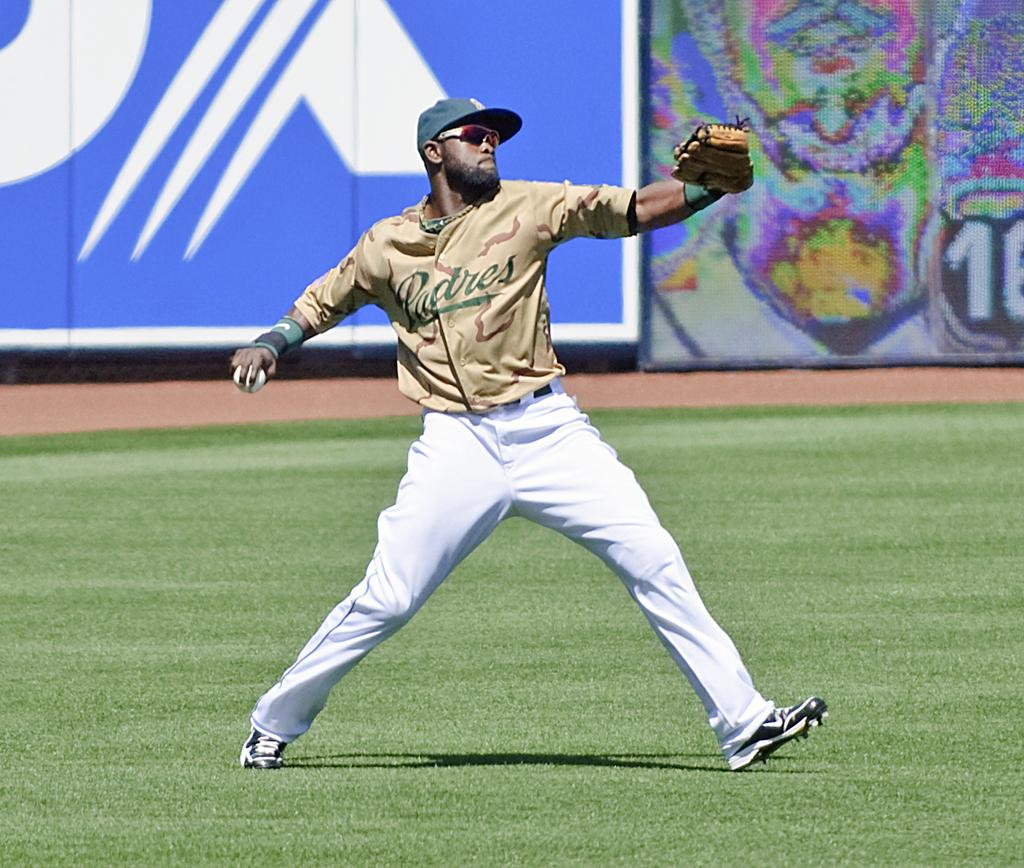Provide a one-sentence caption for the provided image. Man wearing a Padres jersey about to pitch a ball. 